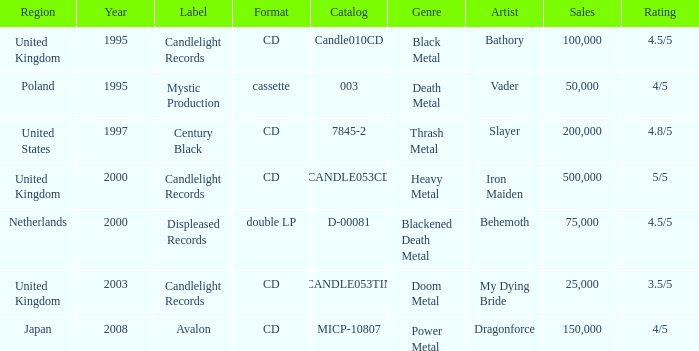What is Candlelight Records format? CD, CD, CD. 